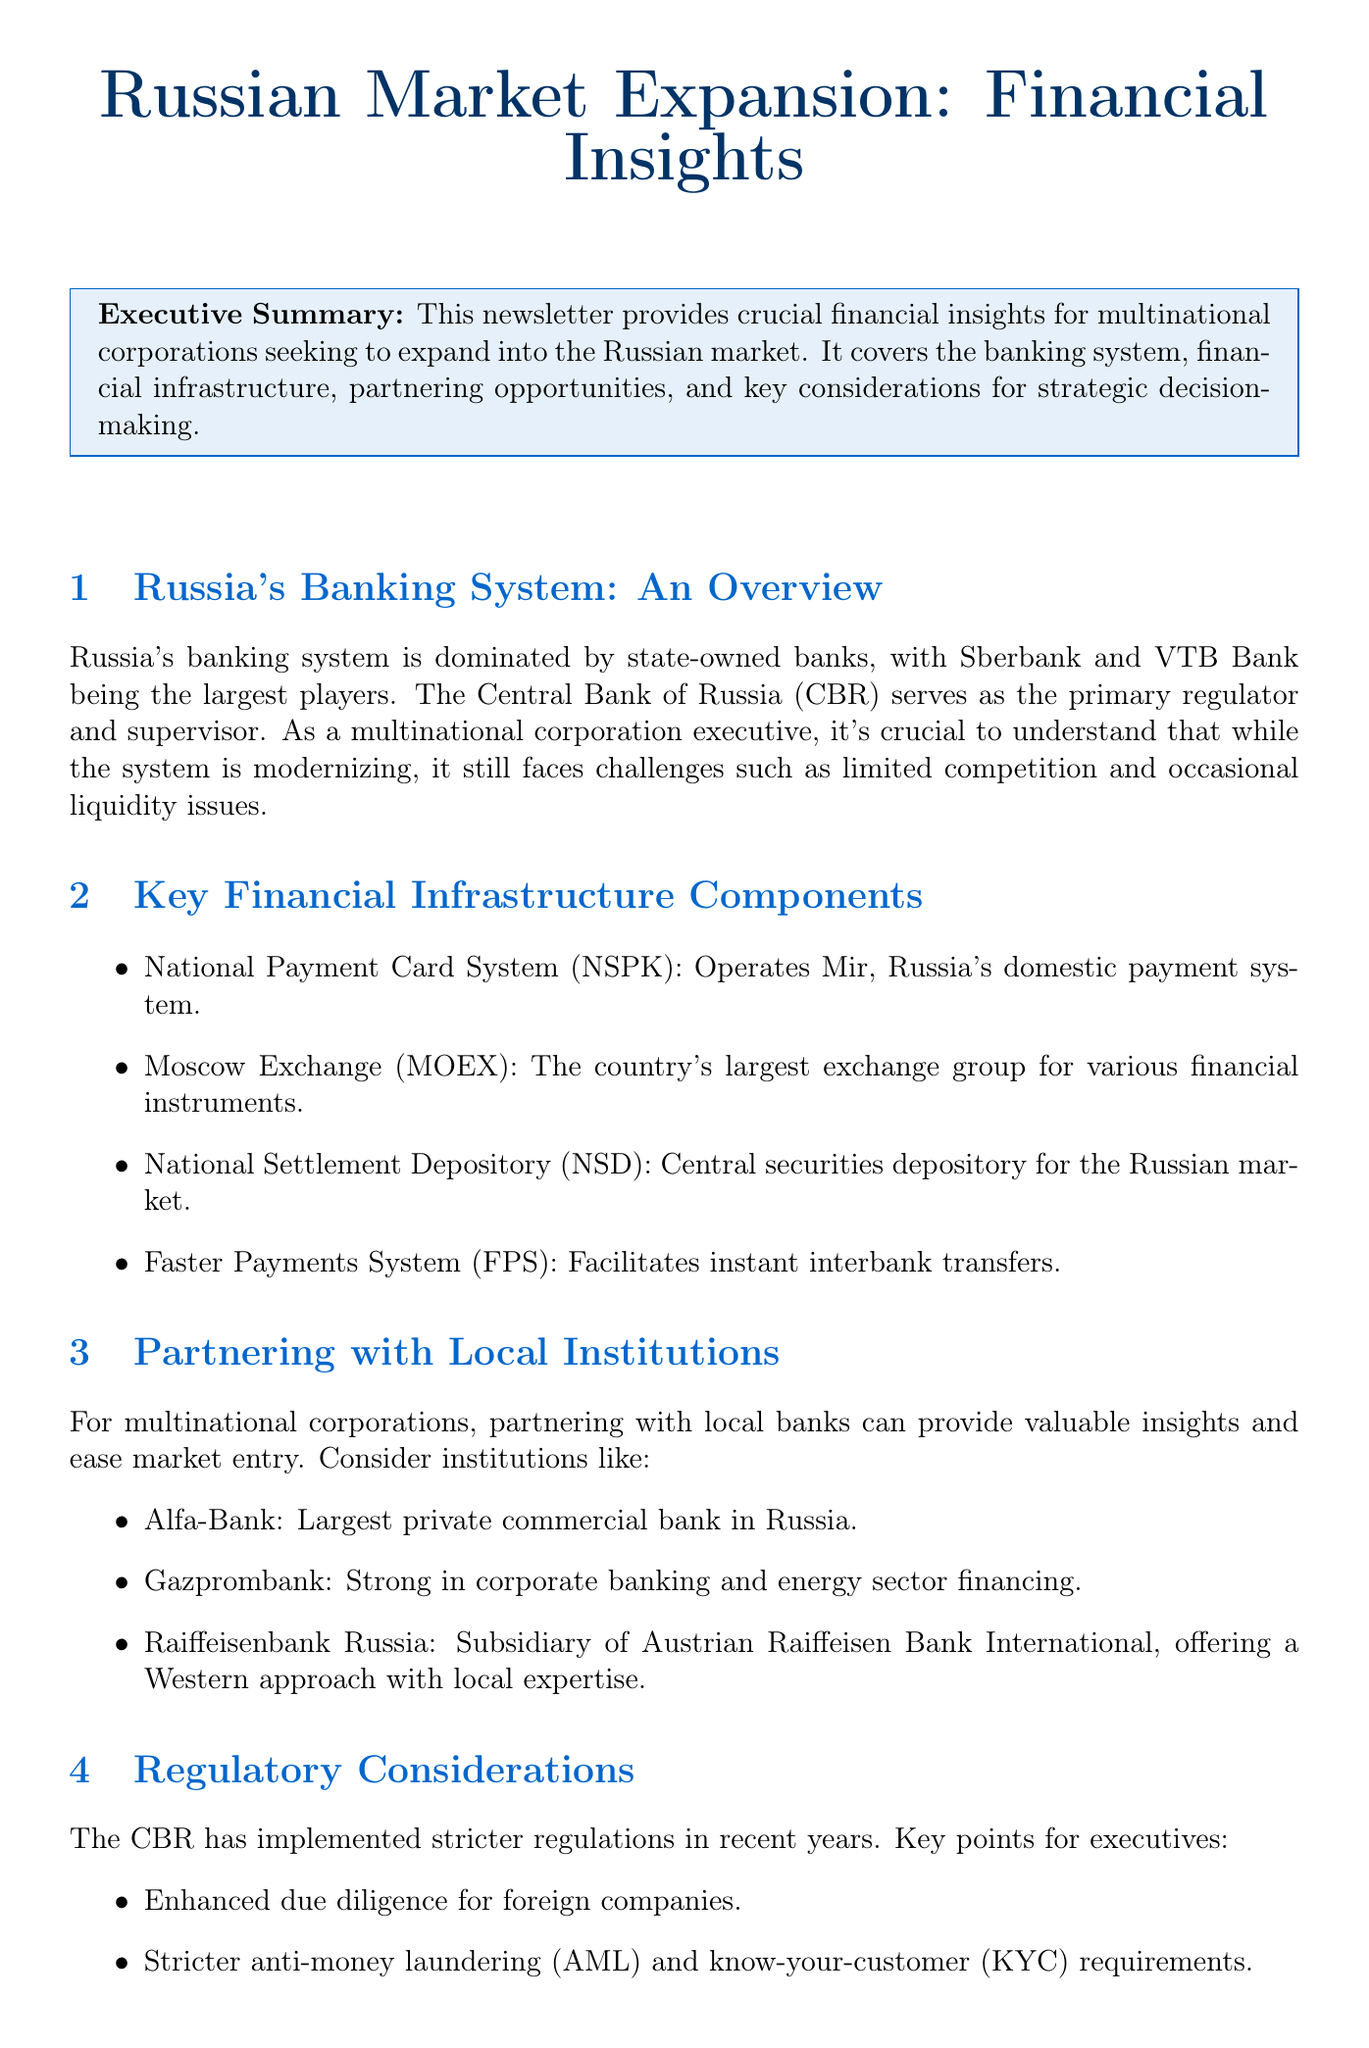What are the largest state-owned banks in Russia? The document mentions Sberbank and VTB Bank as the largest players in Russia's banking system.
Answer: Sberbank and VTB Bank What is the role of the Central Bank of Russia? The document states that the Central Bank of Russia (CBR) serves as the primary regulator and supervisor of the banking system.
Answer: Regulator and supervisor Which payment system operates Mir in Russia? The National Payment Card System (NSPK) operates Mir, as noted in the infrastructure section.
Answer: National Payment Card System (NSPK) What type of institution is Alfa-Bank? Alfa-Bank is referred to as the largest private commercial bank in Russia.
Answer: Private commercial bank What recent trend in digital banking is mentioned? The document highlights the leading digital-only bank Tinkoff Bank as a notable development in the fintech sector.
Answer: Tinkoff Bank What are the key regulatory changes for foreign companies? The document lists enhanced due diligence, stricter AML and KYC requirements, and potential limitations on foreign currency transactions for foreign companies.
Answer: Enhanced due diligence, stricter AML and KYC Which company provides a Western approach with local expertise? Raiffeisenbank Russia is identified as a subsidiary offering a Western approach along with local expertise.
Answer: Raiffeisenbank Russia What is a potential risk for multinational executives regarding transactions? The document emphasizes the need to be aware of economic sanctions that could affect financial transactions.
Answer: Economic sanctions How is the fintech sector evolving in Russia? The document notes the rapid evolution of the fintech sector, specifically highlighting developments like the digital ruble exploration by the CBR.
Answer: Rapidly evolving 